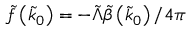Convert formula to latex. <formula><loc_0><loc_0><loc_500><loc_500>\tilde { f } \left ( \tilde { k } _ { 0 } \right ) = - \tilde { \Lambda } \tilde { \beta } \left ( \tilde { k } _ { 0 } \right ) / 4 \pi</formula> 